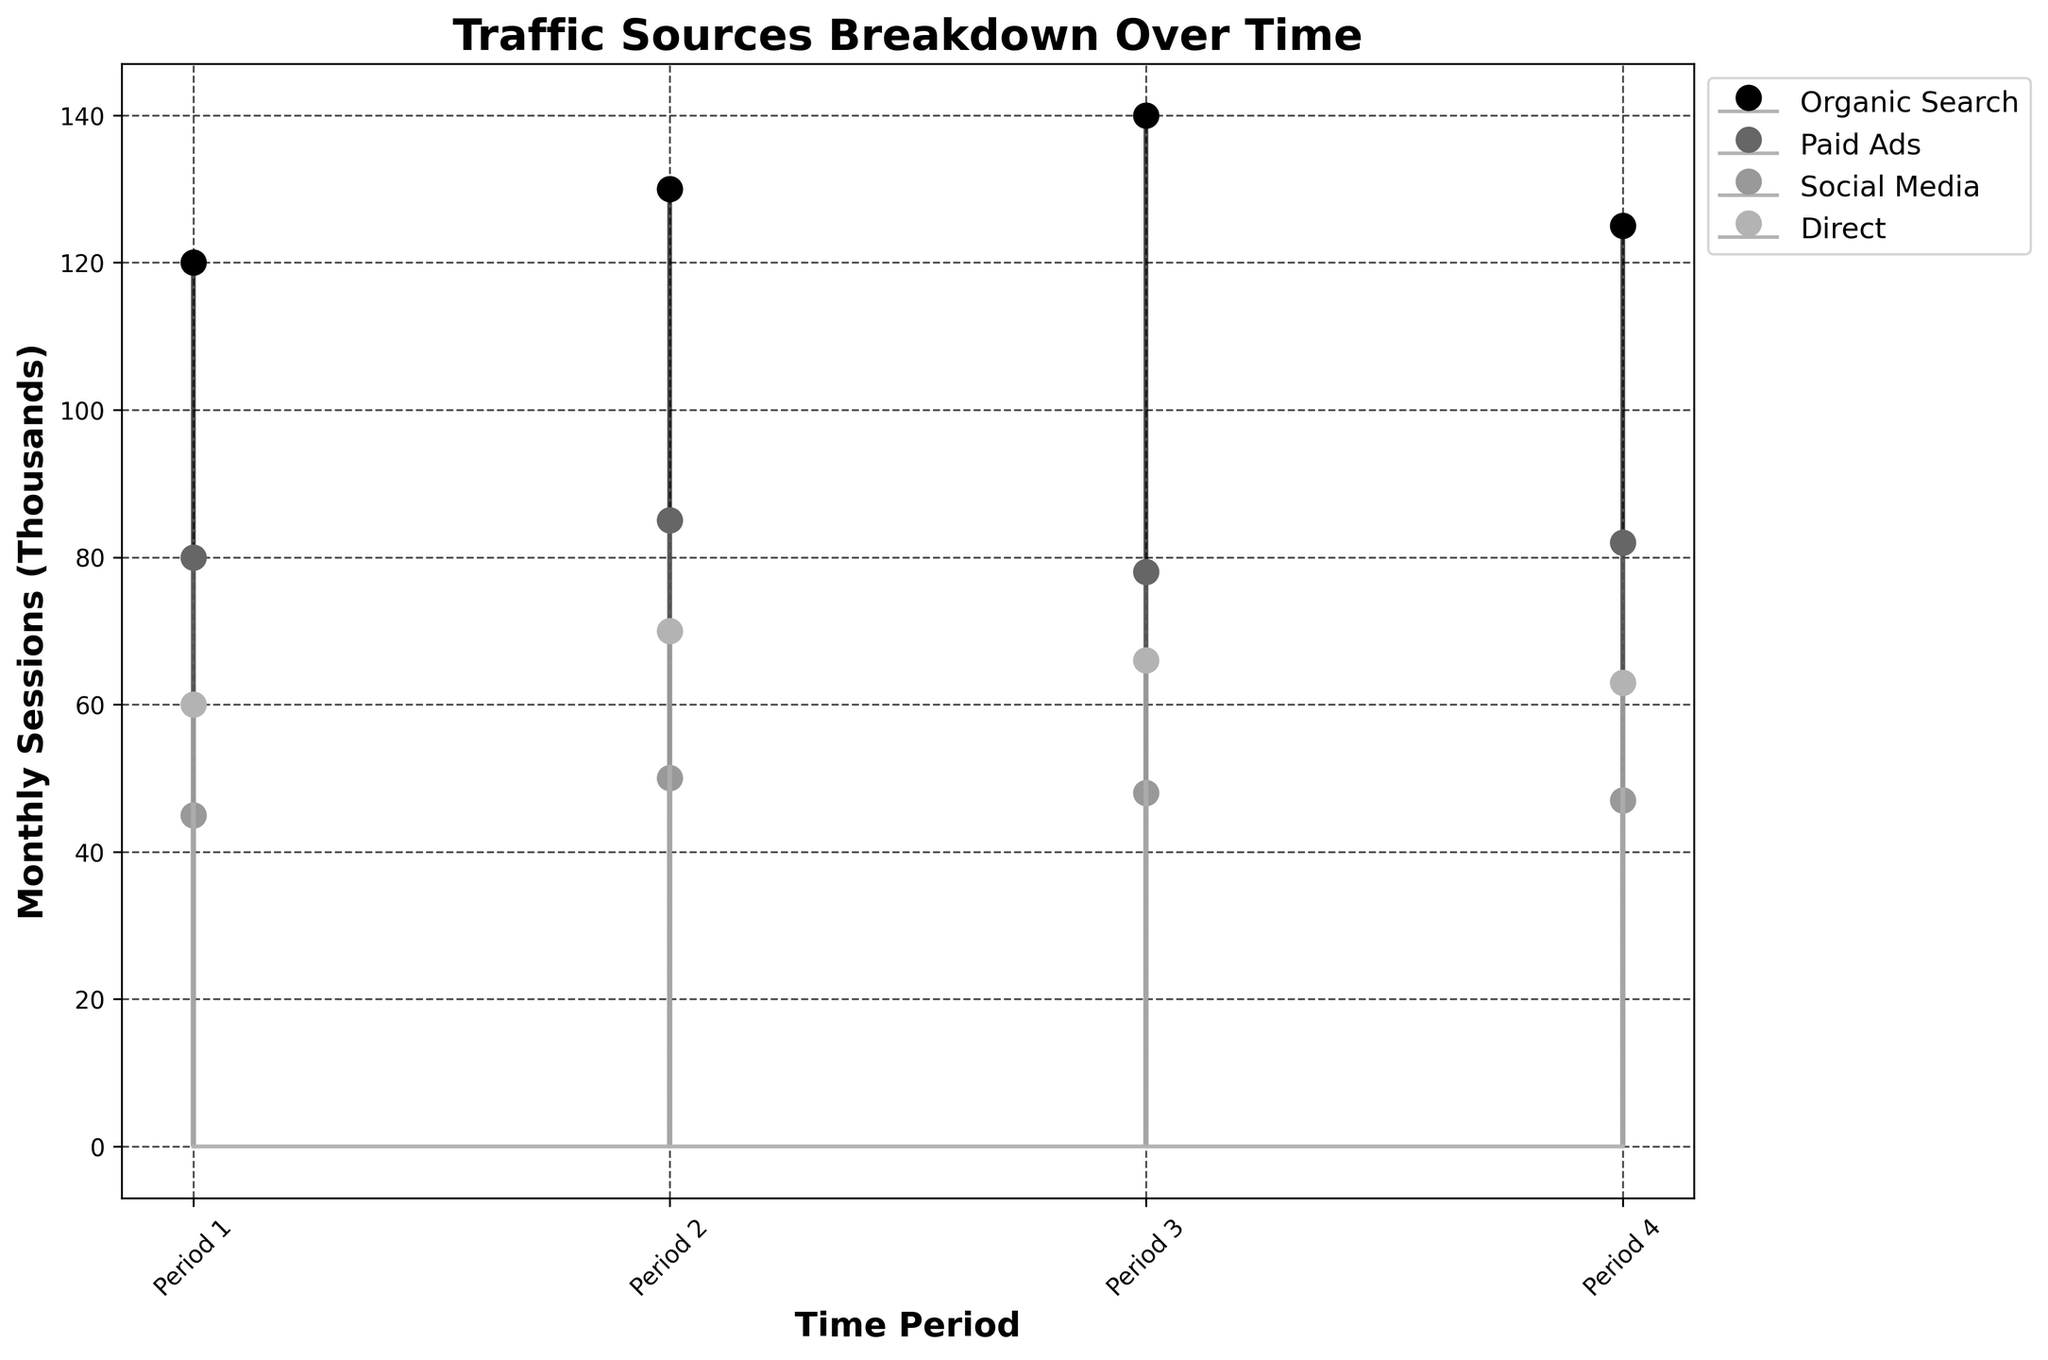what is the title of the plot? The title of the plot is prominently displayed at the top of the figure. It provides a summary of what the plot represents.
Answer: Traffic Sources Breakdown Over Time what's the average monthly session for Organic Search over the time periods? The monthly sessions for Organic Search are (120 + 130 + 140 + 125). Adding them gives 515, and dividing by 4 (the number of periods) gives 128.75.
Answer: 128.75 which traffic source had the highest monthly sessions in Period 3? By looking at the stem plot for Period 3, we compare the top points of each stem to see which is the highest. Organic Search has the highest value at 140.
Answer: Organic Search what is the difference in monthly sessions between Paid Ads and Direct in Period 2? The monthly sessions for Paid Ads in Period 2 are 85 and for Direct are 70. Subtracting these gives 85 - 70 = 15.
Answer: 15 which traffic source shows the most consistent performance over the time periods? Consistency can be visually assessed by looking at the spread of the stems. Social Media stays around 45-50 with the least variance compared to others.
Answer: Social Media what is the median monthly session value for Social Media across the periods? The monthly sessions for Social Media are (45, 50, 48, 47). Sorting them gives (45, 47, 48, 50). The median is the average of the two middle numbers: (47 + 48) / 2 = 47.5.
Answer: 47.5 which traffic source had the lowest monthly sessions in Period 4? By looking at the stem plot for Period 4, the lowest value can be identified. Social Media has the lowest value at 47.
Answer: Social Media how many time periods are represented in the plot? By checking the number of x-ticks on the plot, which are labeled as Period 1, Period 2, Period 3, and Period 4, it is clear there are four periods.
Answer: 4 